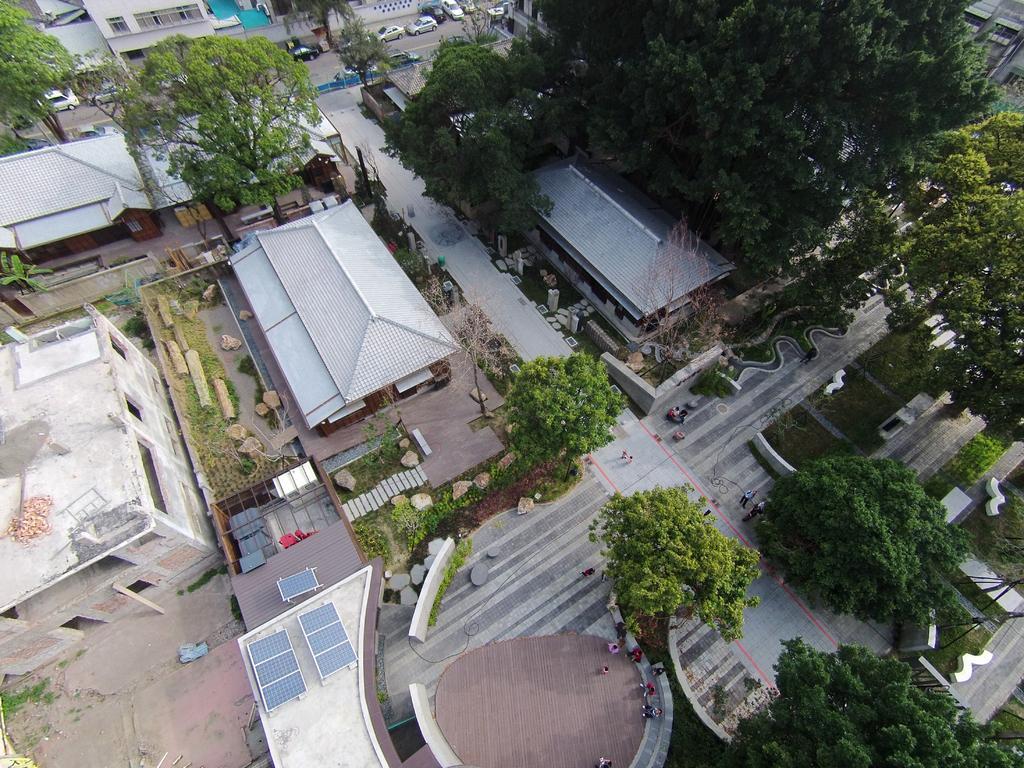In one or two sentences, can you explain what this image depicts? This is a top view of a city. In this image there are buildings, trees and few vehicles are on the road. 